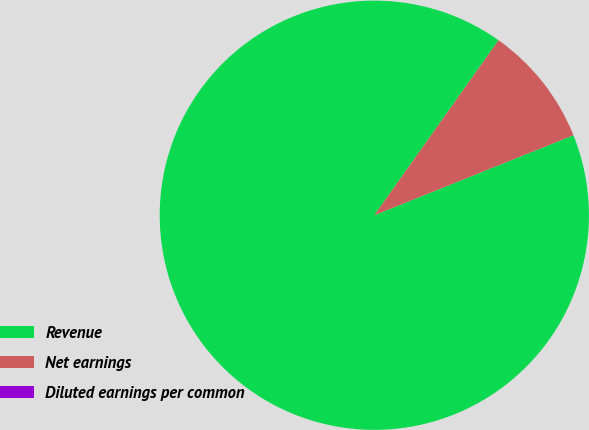Convert chart. <chart><loc_0><loc_0><loc_500><loc_500><pie_chart><fcel>Revenue<fcel>Net earnings<fcel>Diluted earnings per common<nl><fcel>90.91%<fcel>9.09%<fcel>0.0%<nl></chart> 